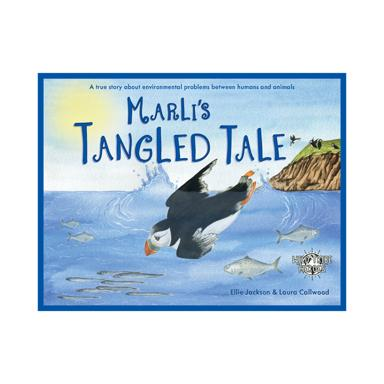What is the title of the children's book mentioned in the image? The title of the featured children's book in the image is 'Marli's Tangled Tale'. This book, crafted by Ellie Jackson and illustrated by Loura Collwood, delves into environmental issues through engaging storytelling. 